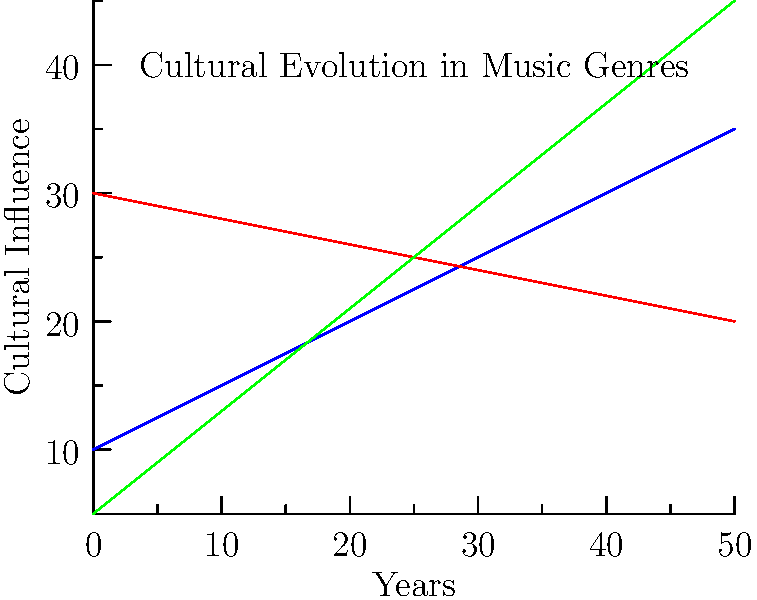Based on the graph depicting the evolution of cultural elements in music genres over time, which genre shows the steepest increase in cultural influence, and what might this suggest about cultural appropriation in the music industry? To answer this question, we need to analyze the graph and interpret its implications:

1. Identify the three genres:
   - Blue line: Traditional
   - Red line: Pop
   - Green line: Fusion

2. Compare the slopes of each line:
   - Traditional (blue): Slight upward slope
   - Pop (red): Downward slope
   - Fusion (green): Steepest upward slope

3. The steepest increase is shown by the Fusion genre (green line).

4. Interpretation of the Fusion genre's steep increase:
   a) Fusion music typically combines elements from different cultural traditions.
   b) The rapid rise suggests a growing popularity and influence of this genre.
   c) This trend could indicate an increasing acceptance and appreciation of multicultural musical elements.

5. Implications for cultural appropriation:
   a) Positive view: It may represent a celebration of cultural diversity and cross-cultural exchange in music.
   b) Critical view: The rapid rise might raise concerns about the commodification of cultural elements without proper acknowledgment or understanding.

6. Anthropological perspective:
   a) This trend highlights the dynamic nature of cultural evolution in music.
   b) It emphasizes the need for nuanced discussions on the boundaries between cultural exchange and appropriation.
   c) The data suggests that further research is needed to understand the sociocultural impacts of this fusion trend.
Answer: Fusion genre; suggests increasing cultural mixing, potentially raising both appreciation and appropriation concerns. 